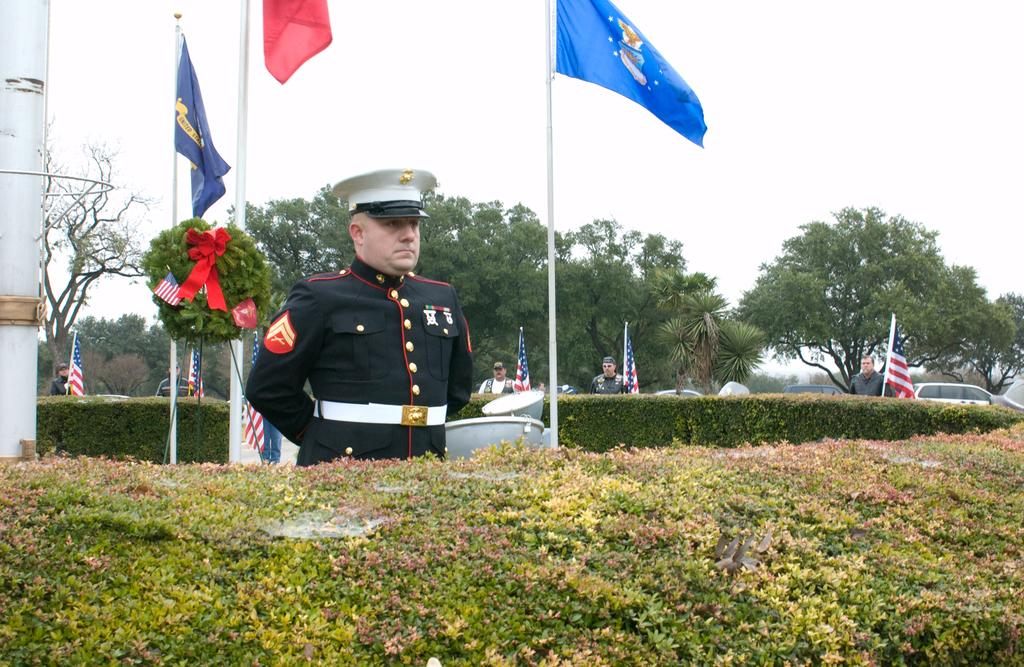What type of living organisms can be seen in the image? Plants and trees are visible in the image. What objects are related to national symbols in the image? Flags are present in the image. What type of vehicles can be seen in the image? Cars are visible in the image. What part of the natural environment is visible in the image? The sky is visible in the image. Where is the toothbrush located in the image? There is no toothbrush present in the image. What type of knee can be seen in the image? There is no knee visible in the image. 